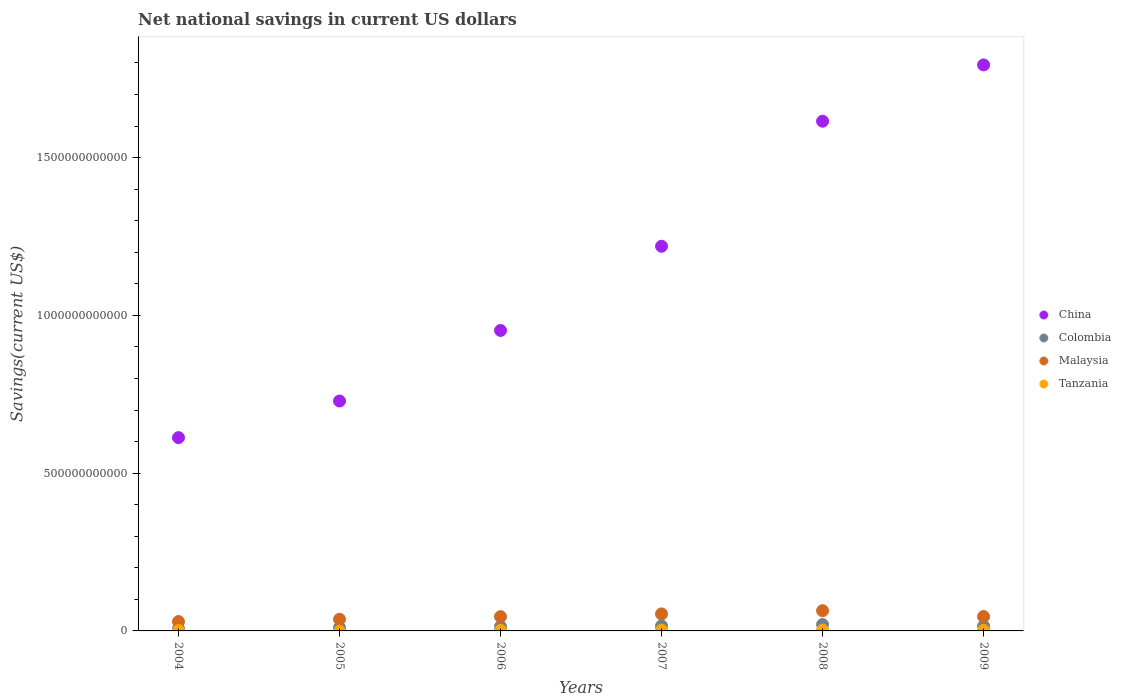How many different coloured dotlines are there?
Offer a terse response. 4. What is the net national savings in Malaysia in 2004?
Keep it short and to the point. 2.97e+1. Across all years, what is the maximum net national savings in China?
Provide a succinct answer. 1.79e+12. Across all years, what is the minimum net national savings in China?
Your answer should be compact. 6.13e+11. What is the total net national savings in Colombia in the graph?
Give a very brief answer. 8.25e+1. What is the difference between the net national savings in Colombia in 2004 and that in 2006?
Your answer should be compact. -6.88e+09. What is the difference between the net national savings in Malaysia in 2005 and the net national savings in Colombia in 2007?
Your response must be concise. 2.09e+1. What is the average net national savings in China per year?
Keep it short and to the point. 1.15e+12. In the year 2006, what is the difference between the net national savings in China and net national savings in Tanzania?
Make the answer very short. 9.50e+11. What is the ratio of the net national savings in Malaysia in 2005 to that in 2006?
Ensure brevity in your answer.  0.82. Is the net national savings in Tanzania in 2007 less than that in 2009?
Your response must be concise. No. What is the difference between the highest and the second highest net national savings in Tanzania?
Provide a succinct answer. 4.57e+08. What is the difference between the highest and the lowest net national savings in Tanzania?
Provide a succinct answer. 2.64e+09. Is it the case that in every year, the sum of the net national savings in Tanzania and net national savings in Colombia  is greater than the sum of net national savings in Malaysia and net national savings in China?
Ensure brevity in your answer.  Yes. Does the net national savings in Tanzania monotonically increase over the years?
Keep it short and to the point. No. Is the net national savings in China strictly greater than the net national savings in Malaysia over the years?
Your answer should be compact. Yes. Is the net national savings in Tanzania strictly less than the net national savings in Malaysia over the years?
Make the answer very short. Yes. How many dotlines are there?
Your answer should be compact. 4. What is the difference between two consecutive major ticks on the Y-axis?
Make the answer very short. 5.00e+11. Are the values on the major ticks of Y-axis written in scientific E-notation?
Ensure brevity in your answer.  No. Does the graph contain any zero values?
Your answer should be compact. Yes. Where does the legend appear in the graph?
Your answer should be compact. Center right. What is the title of the graph?
Give a very brief answer. Net national savings in current US dollars. Does "France" appear as one of the legend labels in the graph?
Offer a terse response. No. What is the label or title of the Y-axis?
Provide a succinct answer. Savings(current US$). What is the Savings(current US$) of China in 2004?
Your answer should be very brief. 6.13e+11. What is the Savings(current US$) in Colombia in 2004?
Offer a very short reply. 7.00e+09. What is the Savings(current US$) in Malaysia in 2004?
Your answer should be compact. 2.97e+1. What is the Savings(current US$) of Tanzania in 2004?
Your response must be concise. 1.30e+09. What is the Savings(current US$) in China in 2005?
Provide a short and direct response. 7.29e+11. What is the Savings(current US$) of Colombia in 2005?
Give a very brief answer. 1.02e+1. What is the Savings(current US$) in Malaysia in 2005?
Keep it short and to the point. 3.70e+1. What is the Savings(current US$) in Tanzania in 2005?
Make the answer very short. 0. What is the Savings(current US$) in China in 2006?
Your response must be concise. 9.52e+11. What is the Savings(current US$) of Colombia in 2006?
Your answer should be compact. 1.39e+1. What is the Savings(current US$) of Malaysia in 2006?
Give a very brief answer. 4.52e+1. What is the Savings(current US$) of Tanzania in 2006?
Your answer should be very brief. 1.87e+09. What is the Savings(current US$) of China in 2007?
Your response must be concise. 1.22e+12. What is the Savings(current US$) of Colombia in 2007?
Offer a terse response. 1.61e+1. What is the Savings(current US$) of Malaysia in 2007?
Make the answer very short. 5.39e+1. What is the Savings(current US$) in Tanzania in 2007?
Provide a succinct answer. 2.19e+09. What is the Savings(current US$) of China in 2008?
Your answer should be compact. 1.62e+12. What is the Savings(current US$) in Colombia in 2008?
Your answer should be very brief. 2.00e+1. What is the Savings(current US$) in Malaysia in 2008?
Offer a very short reply. 6.41e+1. What is the Savings(current US$) of Tanzania in 2008?
Your answer should be very brief. 2.64e+09. What is the Savings(current US$) in China in 2009?
Make the answer very short. 1.79e+12. What is the Savings(current US$) of Colombia in 2009?
Your response must be concise. 1.53e+1. What is the Savings(current US$) in Malaysia in 2009?
Give a very brief answer. 4.56e+1. What is the Savings(current US$) in Tanzania in 2009?
Your answer should be compact. 1.76e+09. Across all years, what is the maximum Savings(current US$) of China?
Your answer should be very brief. 1.79e+12. Across all years, what is the maximum Savings(current US$) in Colombia?
Offer a terse response. 2.00e+1. Across all years, what is the maximum Savings(current US$) in Malaysia?
Make the answer very short. 6.41e+1. Across all years, what is the maximum Savings(current US$) in Tanzania?
Your answer should be very brief. 2.64e+09. Across all years, what is the minimum Savings(current US$) of China?
Your response must be concise. 6.13e+11. Across all years, what is the minimum Savings(current US$) of Colombia?
Offer a terse response. 7.00e+09. Across all years, what is the minimum Savings(current US$) of Malaysia?
Provide a succinct answer. 2.97e+1. What is the total Savings(current US$) of China in the graph?
Your response must be concise. 6.92e+12. What is the total Savings(current US$) of Colombia in the graph?
Make the answer very short. 8.25e+1. What is the total Savings(current US$) in Malaysia in the graph?
Your answer should be compact. 2.75e+11. What is the total Savings(current US$) of Tanzania in the graph?
Your answer should be very brief. 9.77e+09. What is the difference between the Savings(current US$) in China in 2004 and that in 2005?
Offer a very short reply. -1.16e+11. What is the difference between the Savings(current US$) in Colombia in 2004 and that in 2005?
Provide a short and direct response. -3.23e+09. What is the difference between the Savings(current US$) in Malaysia in 2004 and that in 2005?
Provide a short and direct response. -7.28e+09. What is the difference between the Savings(current US$) in China in 2004 and that in 2006?
Your answer should be compact. -3.40e+11. What is the difference between the Savings(current US$) of Colombia in 2004 and that in 2006?
Provide a short and direct response. -6.88e+09. What is the difference between the Savings(current US$) of Malaysia in 2004 and that in 2006?
Offer a terse response. -1.55e+1. What is the difference between the Savings(current US$) of Tanzania in 2004 and that in 2006?
Your answer should be very brief. -5.75e+08. What is the difference between the Savings(current US$) of China in 2004 and that in 2007?
Ensure brevity in your answer.  -6.06e+11. What is the difference between the Savings(current US$) of Colombia in 2004 and that in 2007?
Keep it short and to the point. -9.06e+09. What is the difference between the Savings(current US$) of Malaysia in 2004 and that in 2007?
Offer a very short reply. -2.42e+1. What is the difference between the Savings(current US$) in Tanzania in 2004 and that in 2007?
Your response must be concise. -8.88e+08. What is the difference between the Savings(current US$) in China in 2004 and that in 2008?
Make the answer very short. -1.00e+12. What is the difference between the Savings(current US$) of Colombia in 2004 and that in 2008?
Offer a very short reply. -1.30e+1. What is the difference between the Savings(current US$) in Malaysia in 2004 and that in 2008?
Make the answer very short. -3.44e+1. What is the difference between the Savings(current US$) of Tanzania in 2004 and that in 2008?
Your answer should be compact. -1.34e+09. What is the difference between the Savings(current US$) in China in 2004 and that in 2009?
Ensure brevity in your answer.  -1.18e+12. What is the difference between the Savings(current US$) in Colombia in 2004 and that in 2009?
Ensure brevity in your answer.  -8.34e+09. What is the difference between the Savings(current US$) in Malaysia in 2004 and that in 2009?
Your response must be concise. -1.59e+1. What is the difference between the Savings(current US$) of Tanzania in 2004 and that in 2009?
Provide a succinct answer. -4.63e+08. What is the difference between the Savings(current US$) in China in 2005 and that in 2006?
Your response must be concise. -2.24e+11. What is the difference between the Savings(current US$) in Colombia in 2005 and that in 2006?
Offer a very short reply. -3.65e+09. What is the difference between the Savings(current US$) of Malaysia in 2005 and that in 2006?
Provide a succinct answer. -8.18e+09. What is the difference between the Savings(current US$) in China in 2005 and that in 2007?
Ensure brevity in your answer.  -4.90e+11. What is the difference between the Savings(current US$) of Colombia in 2005 and that in 2007?
Your answer should be very brief. -5.83e+09. What is the difference between the Savings(current US$) of Malaysia in 2005 and that in 2007?
Keep it short and to the point. -1.69e+1. What is the difference between the Savings(current US$) of China in 2005 and that in 2008?
Your answer should be compact. -8.87e+11. What is the difference between the Savings(current US$) of Colombia in 2005 and that in 2008?
Offer a terse response. -9.77e+09. What is the difference between the Savings(current US$) of Malaysia in 2005 and that in 2008?
Keep it short and to the point. -2.71e+1. What is the difference between the Savings(current US$) in China in 2005 and that in 2009?
Provide a succinct answer. -1.07e+12. What is the difference between the Savings(current US$) in Colombia in 2005 and that in 2009?
Your answer should be compact. -5.11e+09. What is the difference between the Savings(current US$) of Malaysia in 2005 and that in 2009?
Offer a very short reply. -8.60e+09. What is the difference between the Savings(current US$) in China in 2006 and that in 2007?
Offer a very short reply. -2.67e+11. What is the difference between the Savings(current US$) in Colombia in 2006 and that in 2007?
Make the answer very short. -2.18e+09. What is the difference between the Savings(current US$) in Malaysia in 2006 and that in 2007?
Make the answer very short. -8.70e+09. What is the difference between the Savings(current US$) in Tanzania in 2006 and that in 2007?
Make the answer very short. -3.13e+08. What is the difference between the Savings(current US$) of China in 2006 and that in 2008?
Make the answer very short. -6.63e+11. What is the difference between the Savings(current US$) in Colombia in 2006 and that in 2008?
Your answer should be very brief. -6.12e+09. What is the difference between the Savings(current US$) in Malaysia in 2006 and that in 2008?
Keep it short and to the point. -1.89e+1. What is the difference between the Savings(current US$) of Tanzania in 2006 and that in 2008?
Offer a terse response. -7.70e+08. What is the difference between the Savings(current US$) in China in 2006 and that in 2009?
Keep it short and to the point. -8.42e+11. What is the difference between the Savings(current US$) of Colombia in 2006 and that in 2009?
Keep it short and to the point. -1.46e+09. What is the difference between the Savings(current US$) of Malaysia in 2006 and that in 2009?
Make the answer very short. -4.18e+08. What is the difference between the Savings(current US$) of Tanzania in 2006 and that in 2009?
Give a very brief answer. 1.12e+08. What is the difference between the Savings(current US$) of China in 2007 and that in 2008?
Provide a short and direct response. -3.96e+11. What is the difference between the Savings(current US$) in Colombia in 2007 and that in 2008?
Your answer should be very brief. -3.94e+09. What is the difference between the Savings(current US$) of Malaysia in 2007 and that in 2008?
Give a very brief answer. -1.02e+1. What is the difference between the Savings(current US$) of Tanzania in 2007 and that in 2008?
Your answer should be very brief. -4.57e+08. What is the difference between the Savings(current US$) of China in 2007 and that in 2009?
Offer a terse response. -5.75e+11. What is the difference between the Savings(current US$) in Colombia in 2007 and that in 2009?
Keep it short and to the point. 7.18e+08. What is the difference between the Savings(current US$) of Malaysia in 2007 and that in 2009?
Ensure brevity in your answer.  8.29e+09. What is the difference between the Savings(current US$) of Tanzania in 2007 and that in 2009?
Make the answer very short. 4.25e+08. What is the difference between the Savings(current US$) in China in 2008 and that in 2009?
Give a very brief answer. -1.78e+11. What is the difference between the Savings(current US$) of Colombia in 2008 and that in 2009?
Provide a short and direct response. 4.66e+09. What is the difference between the Savings(current US$) of Malaysia in 2008 and that in 2009?
Provide a succinct answer. 1.85e+1. What is the difference between the Savings(current US$) of Tanzania in 2008 and that in 2009?
Offer a terse response. 8.82e+08. What is the difference between the Savings(current US$) of China in 2004 and the Savings(current US$) of Colombia in 2005?
Your answer should be compact. 6.02e+11. What is the difference between the Savings(current US$) of China in 2004 and the Savings(current US$) of Malaysia in 2005?
Provide a succinct answer. 5.76e+11. What is the difference between the Savings(current US$) in Colombia in 2004 and the Savings(current US$) in Malaysia in 2005?
Your response must be concise. -3.00e+1. What is the difference between the Savings(current US$) of China in 2004 and the Savings(current US$) of Colombia in 2006?
Offer a terse response. 5.99e+11. What is the difference between the Savings(current US$) in China in 2004 and the Savings(current US$) in Malaysia in 2006?
Make the answer very short. 5.67e+11. What is the difference between the Savings(current US$) of China in 2004 and the Savings(current US$) of Tanzania in 2006?
Offer a terse response. 6.11e+11. What is the difference between the Savings(current US$) of Colombia in 2004 and the Savings(current US$) of Malaysia in 2006?
Offer a very short reply. -3.82e+1. What is the difference between the Savings(current US$) in Colombia in 2004 and the Savings(current US$) in Tanzania in 2006?
Offer a very short reply. 5.13e+09. What is the difference between the Savings(current US$) of Malaysia in 2004 and the Savings(current US$) of Tanzania in 2006?
Make the answer very short. 2.78e+1. What is the difference between the Savings(current US$) in China in 2004 and the Savings(current US$) in Colombia in 2007?
Give a very brief answer. 5.96e+11. What is the difference between the Savings(current US$) in China in 2004 and the Savings(current US$) in Malaysia in 2007?
Make the answer very short. 5.59e+11. What is the difference between the Savings(current US$) in China in 2004 and the Savings(current US$) in Tanzania in 2007?
Offer a very short reply. 6.10e+11. What is the difference between the Savings(current US$) in Colombia in 2004 and the Savings(current US$) in Malaysia in 2007?
Offer a very short reply. -4.69e+1. What is the difference between the Savings(current US$) in Colombia in 2004 and the Savings(current US$) in Tanzania in 2007?
Keep it short and to the point. 4.82e+09. What is the difference between the Savings(current US$) in Malaysia in 2004 and the Savings(current US$) in Tanzania in 2007?
Keep it short and to the point. 2.75e+1. What is the difference between the Savings(current US$) of China in 2004 and the Savings(current US$) of Colombia in 2008?
Ensure brevity in your answer.  5.93e+11. What is the difference between the Savings(current US$) of China in 2004 and the Savings(current US$) of Malaysia in 2008?
Make the answer very short. 5.48e+11. What is the difference between the Savings(current US$) of China in 2004 and the Savings(current US$) of Tanzania in 2008?
Ensure brevity in your answer.  6.10e+11. What is the difference between the Savings(current US$) of Colombia in 2004 and the Savings(current US$) of Malaysia in 2008?
Keep it short and to the point. -5.71e+1. What is the difference between the Savings(current US$) of Colombia in 2004 and the Savings(current US$) of Tanzania in 2008?
Offer a very short reply. 4.36e+09. What is the difference between the Savings(current US$) in Malaysia in 2004 and the Savings(current US$) in Tanzania in 2008?
Give a very brief answer. 2.71e+1. What is the difference between the Savings(current US$) of China in 2004 and the Savings(current US$) of Colombia in 2009?
Your response must be concise. 5.97e+11. What is the difference between the Savings(current US$) in China in 2004 and the Savings(current US$) in Malaysia in 2009?
Provide a short and direct response. 5.67e+11. What is the difference between the Savings(current US$) in China in 2004 and the Savings(current US$) in Tanzania in 2009?
Provide a short and direct response. 6.11e+11. What is the difference between the Savings(current US$) of Colombia in 2004 and the Savings(current US$) of Malaysia in 2009?
Your answer should be compact. -3.86e+1. What is the difference between the Savings(current US$) of Colombia in 2004 and the Savings(current US$) of Tanzania in 2009?
Ensure brevity in your answer.  5.24e+09. What is the difference between the Savings(current US$) in Malaysia in 2004 and the Savings(current US$) in Tanzania in 2009?
Offer a terse response. 2.80e+1. What is the difference between the Savings(current US$) of China in 2005 and the Savings(current US$) of Colombia in 2006?
Offer a terse response. 7.15e+11. What is the difference between the Savings(current US$) of China in 2005 and the Savings(current US$) of Malaysia in 2006?
Offer a very short reply. 6.83e+11. What is the difference between the Savings(current US$) in China in 2005 and the Savings(current US$) in Tanzania in 2006?
Offer a very short reply. 7.27e+11. What is the difference between the Savings(current US$) of Colombia in 2005 and the Savings(current US$) of Malaysia in 2006?
Ensure brevity in your answer.  -3.49e+1. What is the difference between the Savings(current US$) in Colombia in 2005 and the Savings(current US$) in Tanzania in 2006?
Offer a very short reply. 8.36e+09. What is the difference between the Savings(current US$) of Malaysia in 2005 and the Savings(current US$) of Tanzania in 2006?
Give a very brief answer. 3.51e+1. What is the difference between the Savings(current US$) in China in 2005 and the Savings(current US$) in Colombia in 2007?
Your response must be concise. 7.12e+11. What is the difference between the Savings(current US$) in China in 2005 and the Savings(current US$) in Malaysia in 2007?
Provide a succinct answer. 6.75e+11. What is the difference between the Savings(current US$) in China in 2005 and the Savings(current US$) in Tanzania in 2007?
Provide a short and direct response. 7.26e+11. What is the difference between the Savings(current US$) in Colombia in 2005 and the Savings(current US$) in Malaysia in 2007?
Offer a terse response. -4.36e+1. What is the difference between the Savings(current US$) of Colombia in 2005 and the Savings(current US$) of Tanzania in 2007?
Make the answer very short. 8.05e+09. What is the difference between the Savings(current US$) in Malaysia in 2005 and the Savings(current US$) in Tanzania in 2007?
Your response must be concise. 3.48e+1. What is the difference between the Savings(current US$) in China in 2005 and the Savings(current US$) in Colombia in 2008?
Your answer should be very brief. 7.09e+11. What is the difference between the Savings(current US$) in China in 2005 and the Savings(current US$) in Malaysia in 2008?
Your answer should be very brief. 6.64e+11. What is the difference between the Savings(current US$) of China in 2005 and the Savings(current US$) of Tanzania in 2008?
Provide a succinct answer. 7.26e+11. What is the difference between the Savings(current US$) of Colombia in 2005 and the Savings(current US$) of Malaysia in 2008?
Ensure brevity in your answer.  -5.39e+1. What is the difference between the Savings(current US$) in Colombia in 2005 and the Savings(current US$) in Tanzania in 2008?
Your answer should be very brief. 7.59e+09. What is the difference between the Savings(current US$) in Malaysia in 2005 and the Savings(current US$) in Tanzania in 2008?
Offer a terse response. 3.44e+1. What is the difference between the Savings(current US$) in China in 2005 and the Savings(current US$) in Colombia in 2009?
Provide a short and direct response. 7.13e+11. What is the difference between the Savings(current US$) in China in 2005 and the Savings(current US$) in Malaysia in 2009?
Your response must be concise. 6.83e+11. What is the difference between the Savings(current US$) in China in 2005 and the Savings(current US$) in Tanzania in 2009?
Your answer should be very brief. 7.27e+11. What is the difference between the Savings(current US$) in Colombia in 2005 and the Savings(current US$) in Malaysia in 2009?
Offer a terse response. -3.54e+1. What is the difference between the Savings(current US$) of Colombia in 2005 and the Savings(current US$) of Tanzania in 2009?
Your response must be concise. 8.47e+09. What is the difference between the Savings(current US$) of Malaysia in 2005 and the Savings(current US$) of Tanzania in 2009?
Make the answer very short. 3.52e+1. What is the difference between the Savings(current US$) in China in 2006 and the Savings(current US$) in Colombia in 2007?
Your answer should be compact. 9.36e+11. What is the difference between the Savings(current US$) of China in 2006 and the Savings(current US$) of Malaysia in 2007?
Give a very brief answer. 8.98e+11. What is the difference between the Savings(current US$) of China in 2006 and the Savings(current US$) of Tanzania in 2007?
Provide a succinct answer. 9.50e+11. What is the difference between the Savings(current US$) of Colombia in 2006 and the Savings(current US$) of Malaysia in 2007?
Your response must be concise. -4.00e+1. What is the difference between the Savings(current US$) in Colombia in 2006 and the Savings(current US$) in Tanzania in 2007?
Your answer should be very brief. 1.17e+1. What is the difference between the Savings(current US$) of Malaysia in 2006 and the Savings(current US$) of Tanzania in 2007?
Your response must be concise. 4.30e+1. What is the difference between the Savings(current US$) of China in 2006 and the Savings(current US$) of Colombia in 2008?
Offer a terse response. 9.32e+11. What is the difference between the Savings(current US$) of China in 2006 and the Savings(current US$) of Malaysia in 2008?
Provide a succinct answer. 8.88e+11. What is the difference between the Savings(current US$) in China in 2006 and the Savings(current US$) in Tanzania in 2008?
Provide a short and direct response. 9.49e+11. What is the difference between the Savings(current US$) in Colombia in 2006 and the Savings(current US$) in Malaysia in 2008?
Make the answer very short. -5.02e+1. What is the difference between the Savings(current US$) of Colombia in 2006 and the Savings(current US$) of Tanzania in 2008?
Give a very brief answer. 1.12e+1. What is the difference between the Savings(current US$) of Malaysia in 2006 and the Savings(current US$) of Tanzania in 2008?
Your answer should be very brief. 4.25e+1. What is the difference between the Savings(current US$) in China in 2006 and the Savings(current US$) in Colombia in 2009?
Provide a succinct answer. 9.37e+11. What is the difference between the Savings(current US$) in China in 2006 and the Savings(current US$) in Malaysia in 2009?
Ensure brevity in your answer.  9.07e+11. What is the difference between the Savings(current US$) of China in 2006 and the Savings(current US$) of Tanzania in 2009?
Provide a short and direct response. 9.50e+11. What is the difference between the Savings(current US$) of Colombia in 2006 and the Savings(current US$) of Malaysia in 2009?
Your answer should be very brief. -3.17e+1. What is the difference between the Savings(current US$) of Colombia in 2006 and the Savings(current US$) of Tanzania in 2009?
Your answer should be very brief. 1.21e+1. What is the difference between the Savings(current US$) in Malaysia in 2006 and the Savings(current US$) in Tanzania in 2009?
Your answer should be compact. 4.34e+1. What is the difference between the Savings(current US$) of China in 2007 and the Savings(current US$) of Colombia in 2008?
Make the answer very short. 1.20e+12. What is the difference between the Savings(current US$) of China in 2007 and the Savings(current US$) of Malaysia in 2008?
Give a very brief answer. 1.15e+12. What is the difference between the Savings(current US$) in China in 2007 and the Savings(current US$) in Tanzania in 2008?
Give a very brief answer. 1.22e+12. What is the difference between the Savings(current US$) in Colombia in 2007 and the Savings(current US$) in Malaysia in 2008?
Ensure brevity in your answer.  -4.81e+1. What is the difference between the Savings(current US$) of Colombia in 2007 and the Savings(current US$) of Tanzania in 2008?
Make the answer very short. 1.34e+1. What is the difference between the Savings(current US$) of Malaysia in 2007 and the Savings(current US$) of Tanzania in 2008?
Your answer should be compact. 5.12e+1. What is the difference between the Savings(current US$) in China in 2007 and the Savings(current US$) in Colombia in 2009?
Ensure brevity in your answer.  1.20e+12. What is the difference between the Savings(current US$) of China in 2007 and the Savings(current US$) of Malaysia in 2009?
Your response must be concise. 1.17e+12. What is the difference between the Savings(current US$) in China in 2007 and the Savings(current US$) in Tanzania in 2009?
Your response must be concise. 1.22e+12. What is the difference between the Savings(current US$) of Colombia in 2007 and the Savings(current US$) of Malaysia in 2009?
Provide a succinct answer. -2.95e+1. What is the difference between the Savings(current US$) of Colombia in 2007 and the Savings(current US$) of Tanzania in 2009?
Your answer should be compact. 1.43e+1. What is the difference between the Savings(current US$) of Malaysia in 2007 and the Savings(current US$) of Tanzania in 2009?
Make the answer very short. 5.21e+1. What is the difference between the Savings(current US$) in China in 2008 and the Savings(current US$) in Colombia in 2009?
Your response must be concise. 1.60e+12. What is the difference between the Savings(current US$) of China in 2008 and the Savings(current US$) of Malaysia in 2009?
Your response must be concise. 1.57e+12. What is the difference between the Savings(current US$) of China in 2008 and the Savings(current US$) of Tanzania in 2009?
Provide a succinct answer. 1.61e+12. What is the difference between the Savings(current US$) in Colombia in 2008 and the Savings(current US$) in Malaysia in 2009?
Provide a short and direct response. -2.56e+1. What is the difference between the Savings(current US$) of Colombia in 2008 and the Savings(current US$) of Tanzania in 2009?
Your answer should be compact. 1.82e+1. What is the difference between the Savings(current US$) of Malaysia in 2008 and the Savings(current US$) of Tanzania in 2009?
Offer a very short reply. 6.24e+1. What is the average Savings(current US$) in China per year?
Give a very brief answer. 1.15e+12. What is the average Savings(current US$) of Colombia per year?
Ensure brevity in your answer.  1.38e+1. What is the average Savings(current US$) of Malaysia per year?
Your answer should be compact. 4.59e+1. What is the average Savings(current US$) of Tanzania per year?
Your response must be concise. 1.63e+09. In the year 2004, what is the difference between the Savings(current US$) of China and Savings(current US$) of Colombia?
Give a very brief answer. 6.06e+11. In the year 2004, what is the difference between the Savings(current US$) in China and Savings(current US$) in Malaysia?
Your answer should be very brief. 5.83e+11. In the year 2004, what is the difference between the Savings(current US$) in China and Savings(current US$) in Tanzania?
Your answer should be very brief. 6.11e+11. In the year 2004, what is the difference between the Savings(current US$) of Colombia and Savings(current US$) of Malaysia?
Give a very brief answer. -2.27e+1. In the year 2004, what is the difference between the Savings(current US$) in Colombia and Savings(current US$) in Tanzania?
Your response must be concise. 5.70e+09. In the year 2004, what is the difference between the Savings(current US$) in Malaysia and Savings(current US$) in Tanzania?
Provide a short and direct response. 2.84e+1. In the year 2005, what is the difference between the Savings(current US$) of China and Savings(current US$) of Colombia?
Keep it short and to the point. 7.18e+11. In the year 2005, what is the difference between the Savings(current US$) of China and Savings(current US$) of Malaysia?
Provide a short and direct response. 6.92e+11. In the year 2005, what is the difference between the Savings(current US$) in Colombia and Savings(current US$) in Malaysia?
Keep it short and to the point. -2.68e+1. In the year 2006, what is the difference between the Savings(current US$) of China and Savings(current US$) of Colombia?
Provide a succinct answer. 9.38e+11. In the year 2006, what is the difference between the Savings(current US$) of China and Savings(current US$) of Malaysia?
Your answer should be very brief. 9.07e+11. In the year 2006, what is the difference between the Savings(current US$) in China and Savings(current US$) in Tanzania?
Your answer should be compact. 9.50e+11. In the year 2006, what is the difference between the Savings(current US$) in Colombia and Savings(current US$) in Malaysia?
Offer a very short reply. -3.13e+1. In the year 2006, what is the difference between the Savings(current US$) of Colombia and Savings(current US$) of Tanzania?
Offer a very short reply. 1.20e+1. In the year 2006, what is the difference between the Savings(current US$) in Malaysia and Savings(current US$) in Tanzania?
Your answer should be compact. 4.33e+1. In the year 2007, what is the difference between the Savings(current US$) of China and Savings(current US$) of Colombia?
Give a very brief answer. 1.20e+12. In the year 2007, what is the difference between the Savings(current US$) of China and Savings(current US$) of Malaysia?
Make the answer very short. 1.17e+12. In the year 2007, what is the difference between the Savings(current US$) of China and Savings(current US$) of Tanzania?
Your response must be concise. 1.22e+12. In the year 2007, what is the difference between the Savings(current US$) of Colombia and Savings(current US$) of Malaysia?
Your answer should be very brief. -3.78e+1. In the year 2007, what is the difference between the Savings(current US$) in Colombia and Savings(current US$) in Tanzania?
Ensure brevity in your answer.  1.39e+1. In the year 2007, what is the difference between the Savings(current US$) of Malaysia and Savings(current US$) of Tanzania?
Ensure brevity in your answer.  5.17e+1. In the year 2008, what is the difference between the Savings(current US$) of China and Savings(current US$) of Colombia?
Your response must be concise. 1.60e+12. In the year 2008, what is the difference between the Savings(current US$) in China and Savings(current US$) in Malaysia?
Provide a short and direct response. 1.55e+12. In the year 2008, what is the difference between the Savings(current US$) in China and Savings(current US$) in Tanzania?
Your response must be concise. 1.61e+12. In the year 2008, what is the difference between the Savings(current US$) in Colombia and Savings(current US$) in Malaysia?
Make the answer very short. -4.41e+1. In the year 2008, what is the difference between the Savings(current US$) in Colombia and Savings(current US$) in Tanzania?
Your answer should be very brief. 1.74e+1. In the year 2008, what is the difference between the Savings(current US$) in Malaysia and Savings(current US$) in Tanzania?
Offer a very short reply. 6.15e+1. In the year 2009, what is the difference between the Savings(current US$) of China and Savings(current US$) of Colombia?
Keep it short and to the point. 1.78e+12. In the year 2009, what is the difference between the Savings(current US$) of China and Savings(current US$) of Malaysia?
Your answer should be very brief. 1.75e+12. In the year 2009, what is the difference between the Savings(current US$) of China and Savings(current US$) of Tanzania?
Give a very brief answer. 1.79e+12. In the year 2009, what is the difference between the Savings(current US$) in Colombia and Savings(current US$) in Malaysia?
Offer a very short reply. -3.02e+1. In the year 2009, what is the difference between the Savings(current US$) in Colombia and Savings(current US$) in Tanzania?
Ensure brevity in your answer.  1.36e+1. In the year 2009, what is the difference between the Savings(current US$) in Malaysia and Savings(current US$) in Tanzania?
Ensure brevity in your answer.  4.38e+1. What is the ratio of the Savings(current US$) in China in 2004 to that in 2005?
Make the answer very short. 0.84. What is the ratio of the Savings(current US$) of Colombia in 2004 to that in 2005?
Offer a terse response. 0.68. What is the ratio of the Savings(current US$) in Malaysia in 2004 to that in 2005?
Your answer should be compact. 0.8. What is the ratio of the Savings(current US$) of China in 2004 to that in 2006?
Provide a succinct answer. 0.64. What is the ratio of the Savings(current US$) in Colombia in 2004 to that in 2006?
Make the answer very short. 0.5. What is the ratio of the Savings(current US$) of Malaysia in 2004 to that in 2006?
Offer a very short reply. 0.66. What is the ratio of the Savings(current US$) in Tanzania in 2004 to that in 2006?
Offer a very short reply. 0.69. What is the ratio of the Savings(current US$) of China in 2004 to that in 2007?
Provide a succinct answer. 0.5. What is the ratio of the Savings(current US$) of Colombia in 2004 to that in 2007?
Your response must be concise. 0.44. What is the ratio of the Savings(current US$) of Malaysia in 2004 to that in 2007?
Provide a succinct answer. 0.55. What is the ratio of the Savings(current US$) of Tanzania in 2004 to that in 2007?
Provide a short and direct response. 0.59. What is the ratio of the Savings(current US$) in China in 2004 to that in 2008?
Your answer should be compact. 0.38. What is the ratio of the Savings(current US$) in Colombia in 2004 to that in 2008?
Your answer should be compact. 0.35. What is the ratio of the Savings(current US$) in Malaysia in 2004 to that in 2008?
Make the answer very short. 0.46. What is the ratio of the Savings(current US$) of Tanzania in 2004 to that in 2008?
Your response must be concise. 0.49. What is the ratio of the Savings(current US$) in China in 2004 to that in 2009?
Ensure brevity in your answer.  0.34. What is the ratio of the Savings(current US$) of Colombia in 2004 to that in 2009?
Offer a very short reply. 0.46. What is the ratio of the Savings(current US$) in Malaysia in 2004 to that in 2009?
Your answer should be compact. 0.65. What is the ratio of the Savings(current US$) of Tanzania in 2004 to that in 2009?
Provide a succinct answer. 0.74. What is the ratio of the Savings(current US$) in China in 2005 to that in 2006?
Provide a short and direct response. 0.77. What is the ratio of the Savings(current US$) in Colombia in 2005 to that in 2006?
Your answer should be very brief. 0.74. What is the ratio of the Savings(current US$) in Malaysia in 2005 to that in 2006?
Provide a short and direct response. 0.82. What is the ratio of the Savings(current US$) in China in 2005 to that in 2007?
Provide a succinct answer. 0.6. What is the ratio of the Savings(current US$) in Colombia in 2005 to that in 2007?
Your response must be concise. 0.64. What is the ratio of the Savings(current US$) in Malaysia in 2005 to that in 2007?
Your response must be concise. 0.69. What is the ratio of the Savings(current US$) in China in 2005 to that in 2008?
Provide a succinct answer. 0.45. What is the ratio of the Savings(current US$) of Colombia in 2005 to that in 2008?
Offer a terse response. 0.51. What is the ratio of the Savings(current US$) in Malaysia in 2005 to that in 2008?
Your response must be concise. 0.58. What is the ratio of the Savings(current US$) of China in 2005 to that in 2009?
Make the answer very short. 0.41. What is the ratio of the Savings(current US$) of Colombia in 2005 to that in 2009?
Your response must be concise. 0.67. What is the ratio of the Savings(current US$) of Malaysia in 2005 to that in 2009?
Provide a succinct answer. 0.81. What is the ratio of the Savings(current US$) of China in 2006 to that in 2007?
Give a very brief answer. 0.78. What is the ratio of the Savings(current US$) in Colombia in 2006 to that in 2007?
Provide a short and direct response. 0.86. What is the ratio of the Savings(current US$) of Malaysia in 2006 to that in 2007?
Make the answer very short. 0.84. What is the ratio of the Savings(current US$) in Tanzania in 2006 to that in 2007?
Give a very brief answer. 0.86. What is the ratio of the Savings(current US$) in China in 2006 to that in 2008?
Your response must be concise. 0.59. What is the ratio of the Savings(current US$) in Colombia in 2006 to that in 2008?
Your answer should be very brief. 0.69. What is the ratio of the Savings(current US$) in Malaysia in 2006 to that in 2008?
Your response must be concise. 0.7. What is the ratio of the Savings(current US$) in Tanzania in 2006 to that in 2008?
Offer a terse response. 0.71. What is the ratio of the Savings(current US$) in China in 2006 to that in 2009?
Ensure brevity in your answer.  0.53. What is the ratio of the Savings(current US$) in Colombia in 2006 to that in 2009?
Your answer should be very brief. 0.9. What is the ratio of the Savings(current US$) of Tanzania in 2006 to that in 2009?
Offer a very short reply. 1.06. What is the ratio of the Savings(current US$) in China in 2007 to that in 2008?
Your response must be concise. 0.75. What is the ratio of the Savings(current US$) of Colombia in 2007 to that in 2008?
Provide a succinct answer. 0.8. What is the ratio of the Savings(current US$) in Malaysia in 2007 to that in 2008?
Make the answer very short. 0.84. What is the ratio of the Savings(current US$) in Tanzania in 2007 to that in 2008?
Provide a short and direct response. 0.83. What is the ratio of the Savings(current US$) of China in 2007 to that in 2009?
Provide a short and direct response. 0.68. What is the ratio of the Savings(current US$) of Colombia in 2007 to that in 2009?
Your response must be concise. 1.05. What is the ratio of the Savings(current US$) in Malaysia in 2007 to that in 2009?
Offer a very short reply. 1.18. What is the ratio of the Savings(current US$) in Tanzania in 2007 to that in 2009?
Keep it short and to the point. 1.24. What is the ratio of the Savings(current US$) of China in 2008 to that in 2009?
Offer a terse response. 0.9. What is the ratio of the Savings(current US$) in Colombia in 2008 to that in 2009?
Your answer should be very brief. 1.3. What is the ratio of the Savings(current US$) in Malaysia in 2008 to that in 2009?
Give a very brief answer. 1.41. What is the ratio of the Savings(current US$) of Tanzania in 2008 to that in 2009?
Give a very brief answer. 1.5. What is the difference between the highest and the second highest Savings(current US$) of China?
Offer a very short reply. 1.78e+11. What is the difference between the highest and the second highest Savings(current US$) of Colombia?
Offer a very short reply. 3.94e+09. What is the difference between the highest and the second highest Savings(current US$) in Malaysia?
Your answer should be very brief. 1.02e+1. What is the difference between the highest and the second highest Savings(current US$) of Tanzania?
Give a very brief answer. 4.57e+08. What is the difference between the highest and the lowest Savings(current US$) of China?
Keep it short and to the point. 1.18e+12. What is the difference between the highest and the lowest Savings(current US$) in Colombia?
Your answer should be compact. 1.30e+1. What is the difference between the highest and the lowest Savings(current US$) in Malaysia?
Provide a short and direct response. 3.44e+1. What is the difference between the highest and the lowest Savings(current US$) of Tanzania?
Offer a terse response. 2.64e+09. 